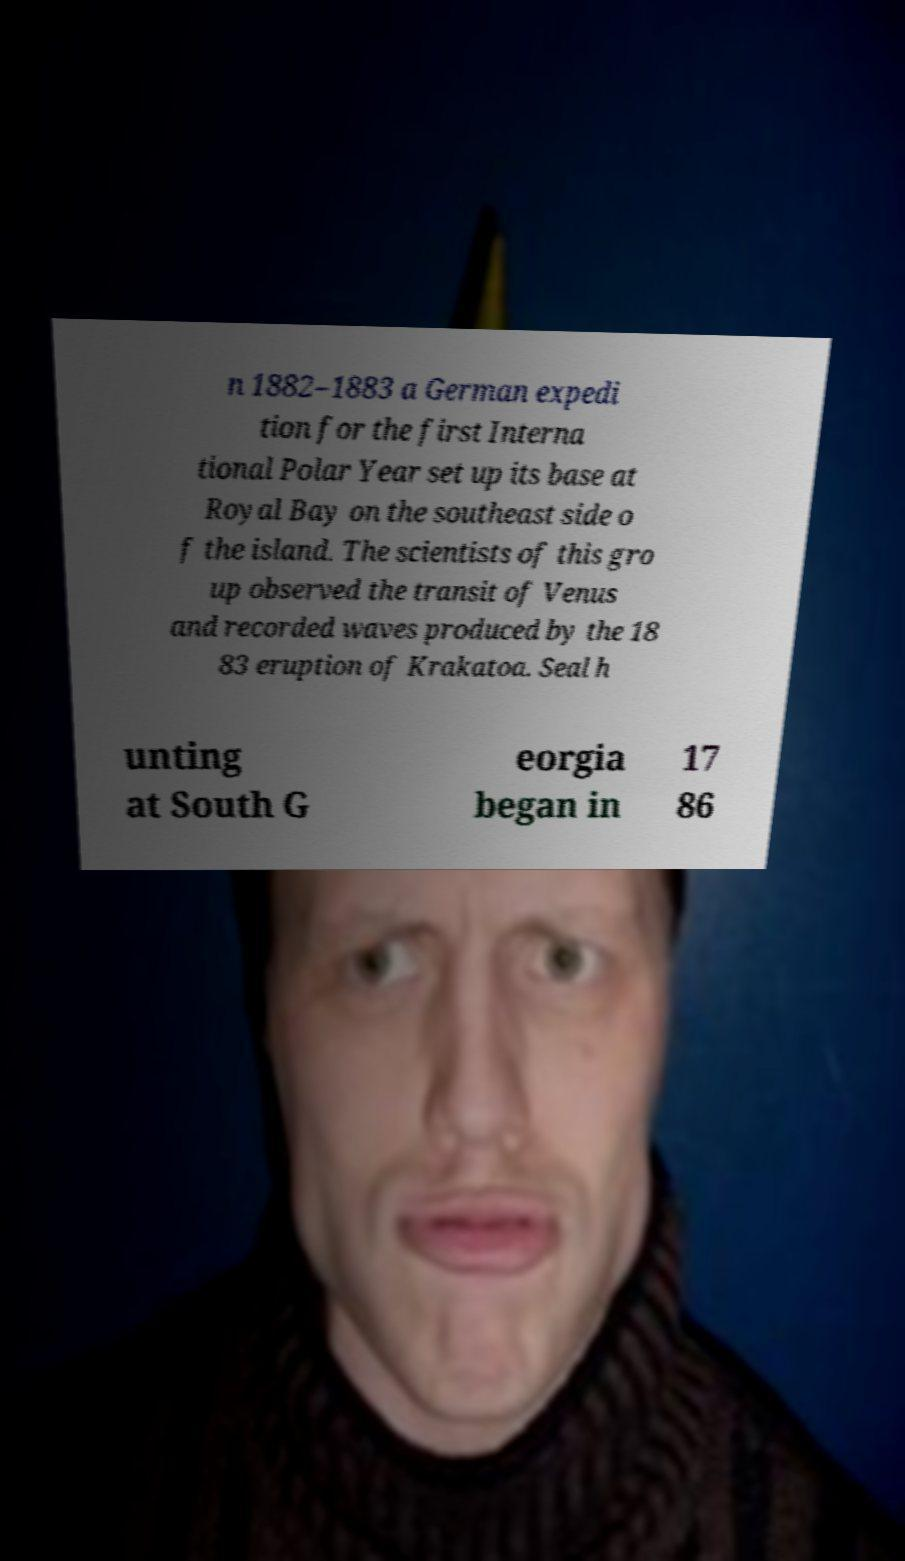I need the written content from this picture converted into text. Can you do that? n 1882–1883 a German expedi tion for the first Interna tional Polar Year set up its base at Royal Bay on the southeast side o f the island. The scientists of this gro up observed the transit of Venus and recorded waves produced by the 18 83 eruption of Krakatoa. Seal h unting at South G eorgia began in 17 86 